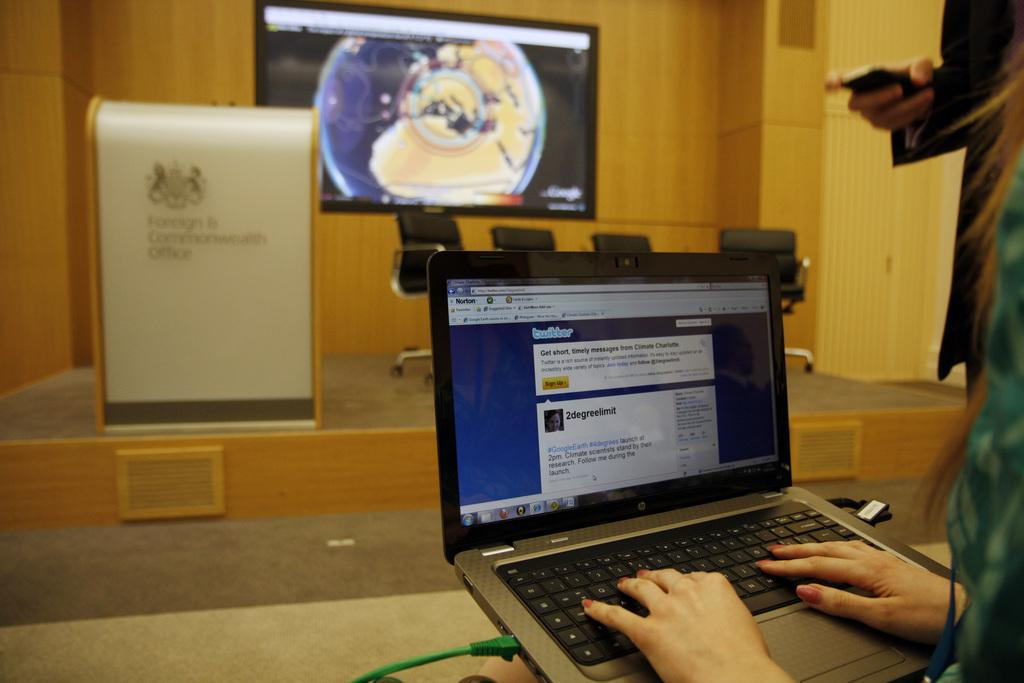<image>
Share a concise interpretation of the image provided. Norton is protecting her computer as she types a message on twitter. 